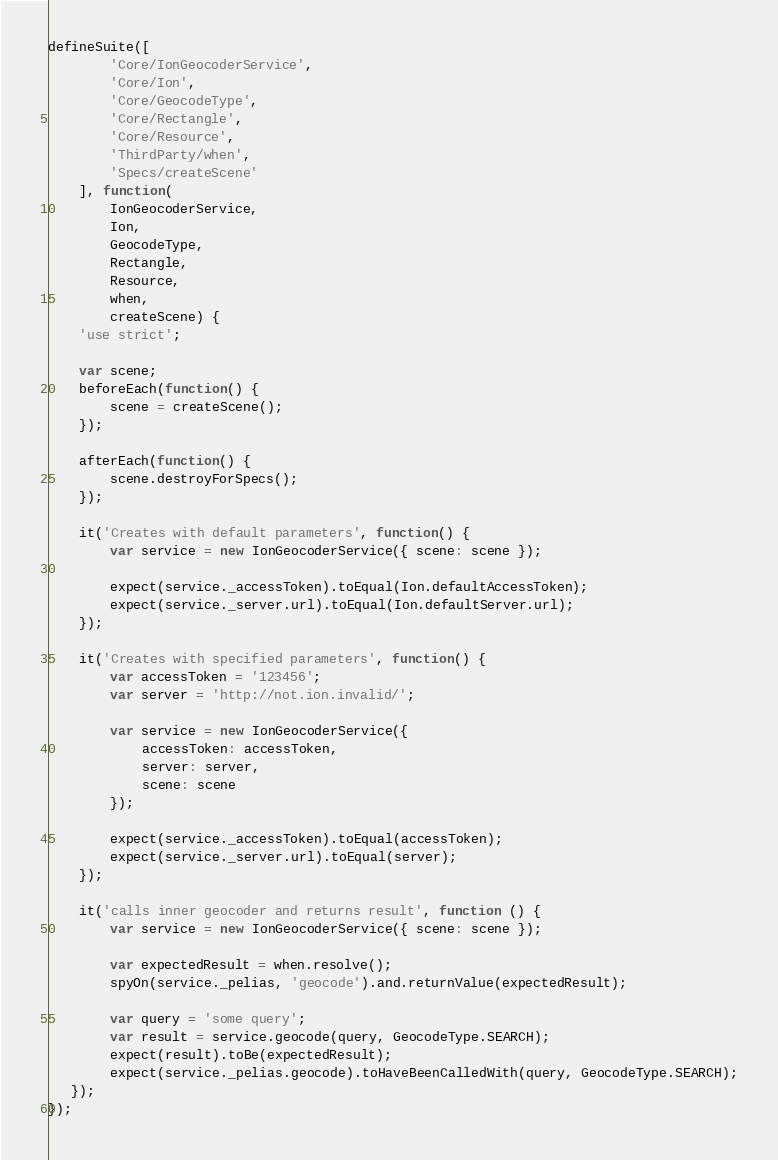Convert code to text. <code><loc_0><loc_0><loc_500><loc_500><_JavaScript_>defineSuite([
        'Core/IonGeocoderService',
        'Core/Ion',
        'Core/GeocodeType',
        'Core/Rectangle',
        'Core/Resource',
        'ThirdParty/when',
        'Specs/createScene'
    ], function(
        IonGeocoderService,
        Ion,
        GeocodeType,
        Rectangle,
        Resource,
        when,
        createScene) {
    'use strict';

    var scene;
    beforeEach(function() {
        scene = createScene();
    });

    afterEach(function() {
        scene.destroyForSpecs();
    });

    it('Creates with default parameters', function() {
        var service = new IonGeocoderService({ scene: scene });

        expect(service._accessToken).toEqual(Ion.defaultAccessToken);
        expect(service._server.url).toEqual(Ion.defaultServer.url);
    });

    it('Creates with specified parameters', function() {
        var accessToken = '123456';
        var server = 'http://not.ion.invalid/';

        var service = new IonGeocoderService({
            accessToken: accessToken,
            server: server,
            scene: scene
        });

        expect(service._accessToken).toEqual(accessToken);
        expect(service._server.url).toEqual(server);
    });

    it('calls inner geocoder and returns result', function () {
        var service = new IonGeocoderService({ scene: scene });

        var expectedResult = when.resolve();
        spyOn(service._pelias, 'geocode').and.returnValue(expectedResult);

        var query = 'some query';
        var result = service.geocode(query, GeocodeType.SEARCH);
        expect(result).toBe(expectedResult);
        expect(service._pelias.geocode).toHaveBeenCalledWith(query, GeocodeType.SEARCH);
   });
});
</code> 